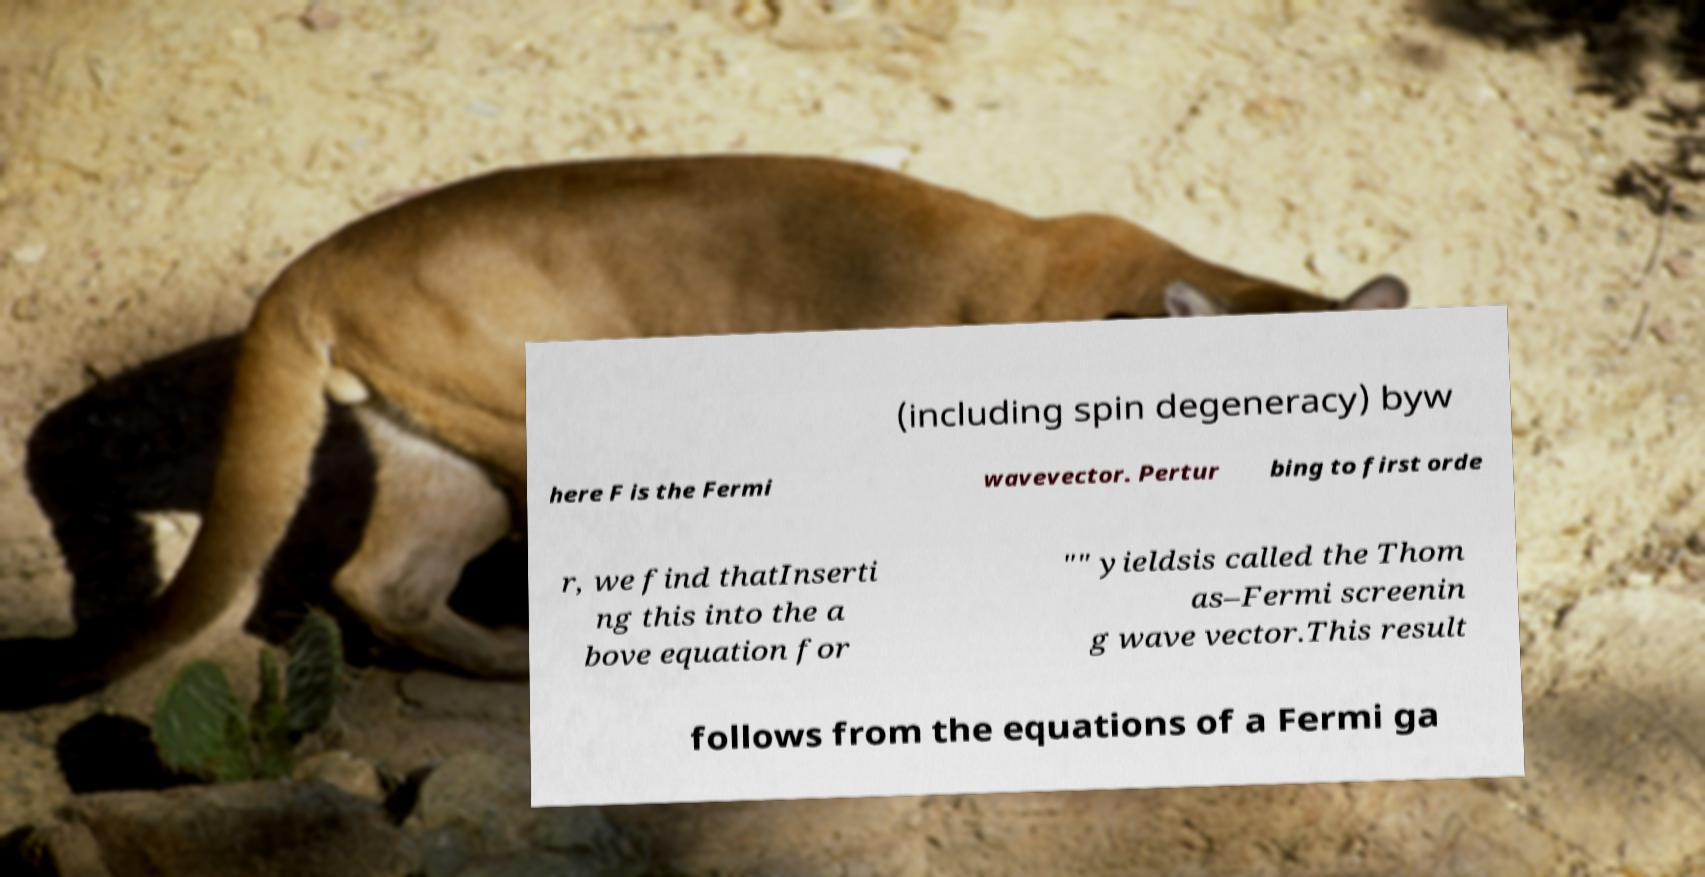Please identify and transcribe the text found in this image. (including spin degeneracy) byw here F is the Fermi wavevector. Pertur bing to first orde r, we find thatInserti ng this into the a bove equation for "" yieldsis called the Thom as–Fermi screenin g wave vector.This result follows from the equations of a Fermi ga 